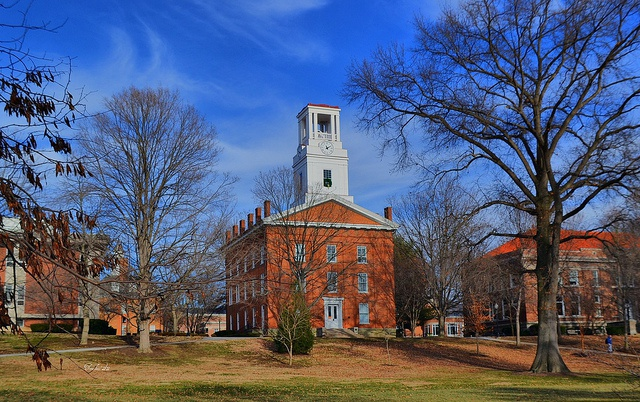Describe the objects in this image and their specific colors. I can see clock in blue, darkgray, and lightgray tones and people in blue, navy, gray, and black tones in this image. 